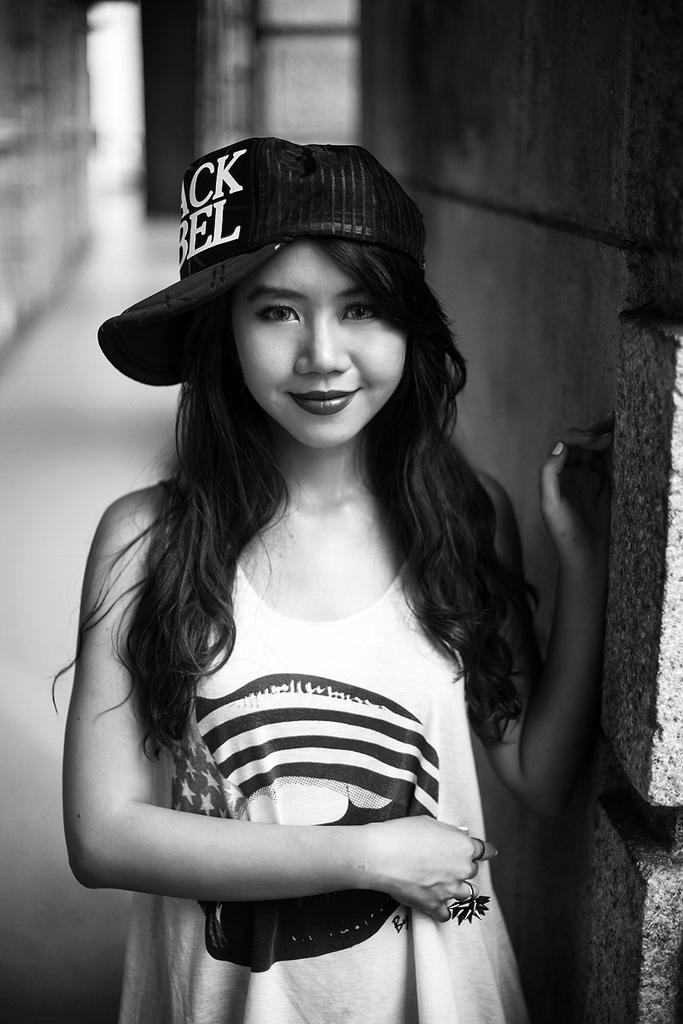What type of structure is visible in the image? There are walls in the image. Can you describe the person near the wall? There is a girl standing near the wall. What is the girl doing in relation to the wall? The girl is touching the wall. What is the girl's purpose for touching the wall in the image? There is no information provided about the girl's purpose for touching the wall, so we cannot determine her motivation from the image. 